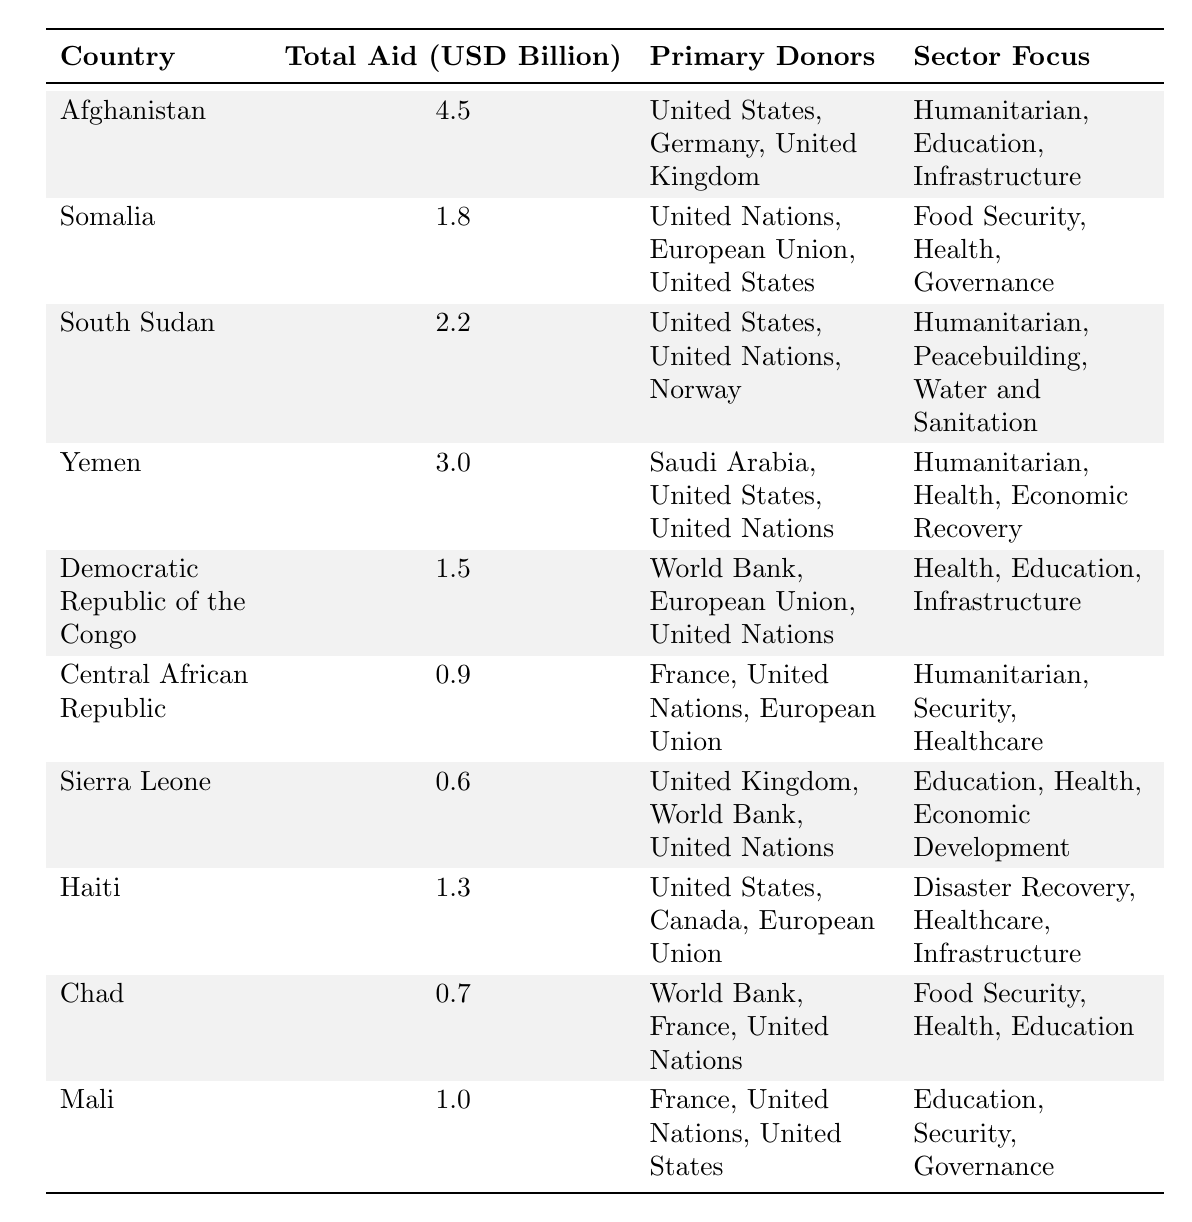What is the total foreign aid allocated to Afghanistan? The table shows that the total aid allocated to Afghanistan is listed directly under the "Total Aid (USD Billion)" column. The value provided is 4.5 billion USD.
Answer: 4.5 billion USD Which country received the least amount of foreign aid in 2023? By comparing the values in the "Total Aid (USD Billion)" column, Central African Republic has the lowest allocation at 0.9 billion USD, which is less than all other countries listed.
Answer: Central African Republic What are the primary donors to South Sudan? The primary donors to South Sudan are provided in the "Primary Donors" column. They are United States, United Nations, and Norway, listed as they appear in that row.
Answer: United States, United Nations, Norway Which country focuses on Economic Recovery as a sector? From the "Sector Focus" column, Yemen is the only country that lists Economic Recovery among its sector focuses, indicating this as a primary concern for aid allocation.
Answer: Yemen What is the total foreign aid allocated to countries focusing on Education? To find this total, we sum the aid allocations for Afghanistan, Democratic Republic of the Congo, Sierra Leone, Haiti, and Mali, which are 4.5, 1.5, 0.6, 1.3, and 1.0 billion USD respectively. The total is 4.5 + 1.5 + 0.6 + 1.3 + 1.0 = 9.9 billion USD.
Answer: 9.9 billion USD Do any of the listed countries receive aid from the United Nations? Checking the "Primary Donors" column for each country, it's evident that multiple countries such as South Sudan, Somalia, Yemen, Central African Republic, and Democratic Republic of the Congo receive aid from the United Nations.
Answer: Yes Which country has the highest total aid allocation focused on humanitarian efforts? Afghanistan and Yemen both list humanitarian as a primary sector focus. The total aid allocations are 4.5 billion USD and 3.0 billion USD respectively. Afghanistan has the higher allocation.
Answer: Afghanistan What is the combined aid allocation of the top three countries receiving foreign aid? The top three countries by total aid allocation are Afghanistan (4.5 billion USD), Yemen (3.0 billion USD), and South Sudan (2.2 billion USD. To find the combined total: 4.5 + 3.0 + 2.2 = 9.7 billion USD.
Answer: 9.7 billion USD Are there any countries where France is one of the primary donors? The table lists France as a primary donor in the Central African Republic and Chad. Thus, both of these countries receive aid from France according to the data provided.
Answer: Yes How much more foreign aid does Afghanistan receive compared to Democratic Republic of the Congo? To find the difference, we subtract the aid amount for the Democratic Republic of the Congo (1.5 billion USD) from that of Afghanistan (4.5 billion USD): 4.5 - 1.5 = 3.0 billion USD.
Answer: 3.0 billion USD 